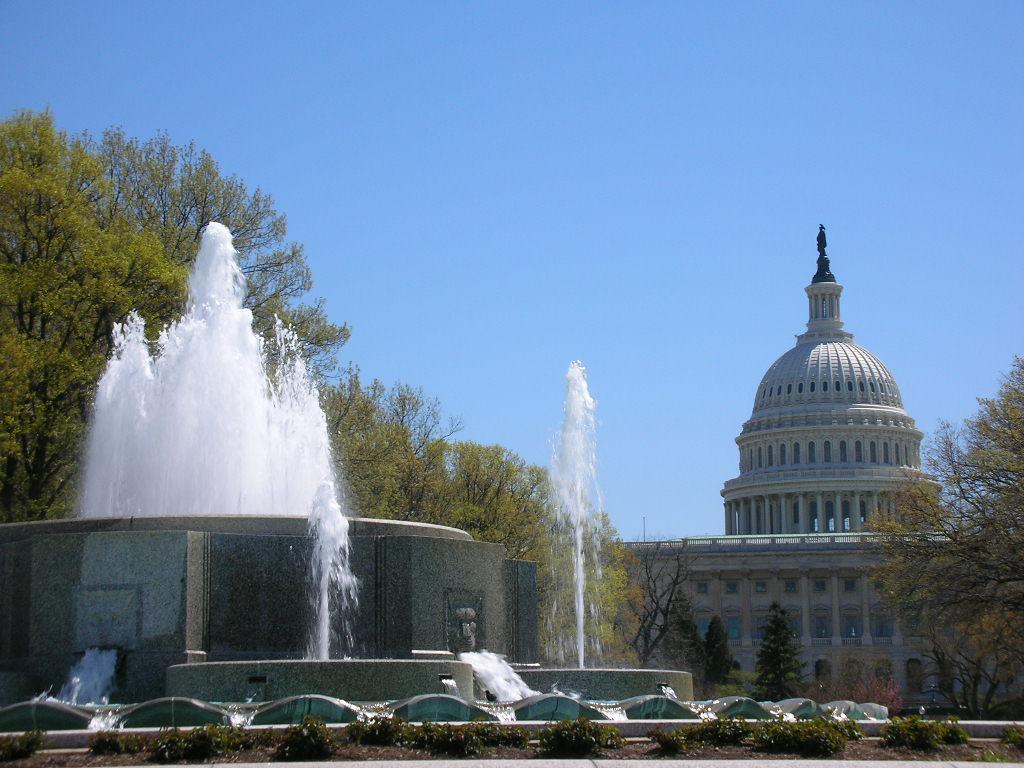How would you summarize this image in a sentence or two? In this image we can see water, fountain, plants on the ground, trees, building and sky. 